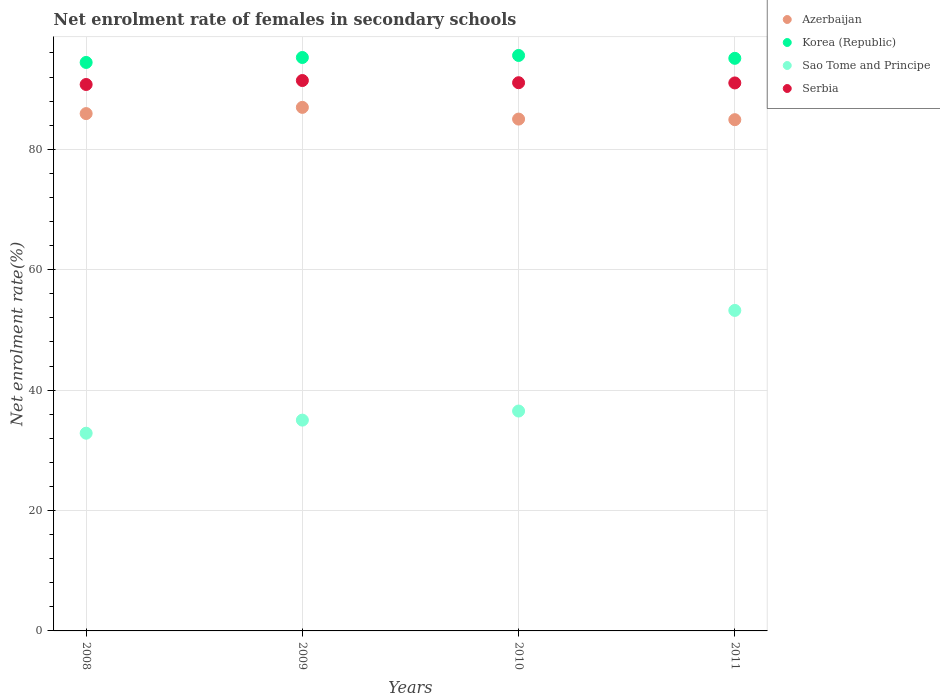How many different coloured dotlines are there?
Offer a very short reply. 4. Is the number of dotlines equal to the number of legend labels?
Provide a succinct answer. Yes. What is the net enrolment rate of females in secondary schools in Korea (Republic) in 2010?
Keep it short and to the point. 95.58. Across all years, what is the maximum net enrolment rate of females in secondary schools in Korea (Republic)?
Your answer should be compact. 95.58. Across all years, what is the minimum net enrolment rate of females in secondary schools in Sao Tome and Principe?
Ensure brevity in your answer.  32.84. In which year was the net enrolment rate of females in secondary schools in Korea (Republic) maximum?
Provide a succinct answer. 2010. What is the total net enrolment rate of females in secondary schools in Sao Tome and Principe in the graph?
Your response must be concise. 157.6. What is the difference between the net enrolment rate of females in secondary schools in Sao Tome and Principe in 2008 and that in 2009?
Provide a succinct answer. -2.17. What is the difference between the net enrolment rate of females in secondary schools in Sao Tome and Principe in 2008 and the net enrolment rate of females in secondary schools in Azerbaijan in 2010?
Provide a short and direct response. -52.17. What is the average net enrolment rate of females in secondary schools in Azerbaijan per year?
Your answer should be compact. 85.7. In the year 2008, what is the difference between the net enrolment rate of females in secondary schools in Azerbaijan and net enrolment rate of females in secondary schools in Sao Tome and Principe?
Your answer should be compact. 53.08. In how many years, is the net enrolment rate of females in secondary schools in Serbia greater than 32 %?
Make the answer very short. 4. What is the ratio of the net enrolment rate of females in secondary schools in Sao Tome and Principe in 2008 to that in 2009?
Offer a very short reply. 0.94. Is the difference between the net enrolment rate of females in secondary schools in Azerbaijan in 2010 and 2011 greater than the difference between the net enrolment rate of females in secondary schools in Sao Tome and Principe in 2010 and 2011?
Make the answer very short. Yes. What is the difference between the highest and the second highest net enrolment rate of females in secondary schools in Serbia?
Your answer should be compact. 0.36. What is the difference between the highest and the lowest net enrolment rate of females in secondary schools in Serbia?
Ensure brevity in your answer.  0.66. Is it the case that in every year, the sum of the net enrolment rate of females in secondary schools in Serbia and net enrolment rate of females in secondary schools in Azerbaijan  is greater than the sum of net enrolment rate of females in secondary schools in Sao Tome and Principe and net enrolment rate of females in secondary schools in Korea (Republic)?
Ensure brevity in your answer.  Yes. How many dotlines are there?
Provide a succinct answer. 4. What is the difference between two consecutive major ticks on the Y-axis?
Provide a succinct answer. 20. Does the graph contain any zero values?
Give a very brief answer. No. Does the graph contain grids?
Your answer should be compact. Yes. Where does the legend appear in the graph?
Your answer should be very brief. Top right. How many legend labels are there?
Ensure brevity in your answer.  4. What is the title of the graph?
Give a very brief answer. Net enrolment rate of females in secondary schools. Does "Vietnam" appear as one of the legend labels in the graph?
Offer a very short reply. No. What is the label or title of the X-axis?
Give a very brief answer. Years. What is the label or title of the Y-axis?
Make the answer very short. Net enrolment rate(%). What is the Net enrolment rate(%) in Azerbaijan in 2008?
Offer a terse response. 85.92. What is the Net enrolment rate(%) of Korea (Republic) in 2008?
Make the answer very short. 94.42. What is the Net enrolment rate(%) of Sao Tome and Principe in 2008?
Provide a succinct answer. 32.84. What is the Net enrolment rate(%) in Serbia in 2008?
Make the answer very short. 90.76. What is the Net enrolment rate(%) in Azerbaijan in 2009?
Ensure brevity in your answer.  86.96. What is the Net enrolment rate(%) of Korea (Republic) in 2009?
Keep it short and to the point. 95.24. What is the Net enrolment rate(%) of Sao Tome and Principe in 2009?
Keep it short and to the point. 35.01. What is the Net enrolment rate(%) in Serbia in 2009?
Keep it short and to the point. 91.42. What is the Net enrolment rate(%) in Azerbaijan in 2010?
Your answer should be very brief. 85.01. What is the Net enrolment rate(%) in Korea (Republic) in 2010?
Give a very brief answer. 95.58. What is the Net enrolment rate(%) in Sao Tome and Principe in 2010?
Ensure brevity in your answer.  36.52. What is the Net enrolment rate(%) in Serbia in 2010?
Your answer should be very brief. 91.05. What is the Net enrolment rate(%) in Azerbaijan in 2011?
Provide a short and direct response. 84.91. What is the Net enrolment rate(%) of Korea (Republic) in 2011?
Your answer should be very brief. 95.1. What is the Net enrolment rate(%) of Sao Tome and Principe in 2011?
Provide a short and direct response. 53.23. What is the Net enrolment rate(%) in Serbia in 2011?
Make the answer very short. 91.01. Across all years, what is the maximum Net enrolment rate(%) of Azerbaijan?
Offer a very short reply. 86.96. Across all years, what is the maximum Net enrolment rate(%) in Korea (Republic)?
Your response must be concise. 95.58. Across all years, what is the maximum Net enrolment rate(%) of Sao Tome and Principe?
Your answer should be very brief. 53.23. Across all years, what is the maximum Net enrolment rate(%) of Serbia?
Give a very brief answer. 91.42. Across all years, what is the minimum Net enrolment rate(%) in Azerbaijan?
Your answer should be compact. 84.91. Across all years, what is the minimum Net enrolment rate(%) of Korea (Republic)?
Keep it short and to the point. 94.42. Across all years, what is the minimum Net enrolment rate(%) of Sao Tome and Principe?
Give a very brief answer. 32.84. Across all years, what is the minimum Net enrolment rate(%) in Serbia?
Your answer should be very brief. 90.76. What is the total Net enrolment rate(%) of Azerbaijan in the graph?
Offer a very short reply. 342.8. What is the total Net enrolment rate(%) of Korea (Republic) in the graph?
Your response must be concise. 380.34. What is the total Net enrolment rate(%) of Sao Tome and Principe in the graph?
Provide a short and direct response. 157.6. What is the total Net enrolment rate(%) in Serbia in the graph?
Your answer should be very brief. 364.24. What is the difference between the Net enrolment rate(%) in Azerbaijan in 2008 and that in 2009?
Your answer should be compact. -1.03. What is the difference between the Net enrolment rate(%) in Korea (Republic) in 2008 and that in 2009?
Your answer should be compact. -0.82. What is the difference between the Net enrolment rate(%) of Sao Tome and Principe in 2008 and that in 2009?
Ensure brevity in your answer.  -2.17. What is the difference between the Net enrolment rate(%) in Serbia in 2008 and that in 2009?
Give a very brief answer. -0.66. What is the difference between the Net enrolment rate(%) of Azerbaijan in 2008 and that in 2010?
Give a very brief answer. 0.91. What is the difference between the Net enrolment rate(%) in Korea (Republic) in 2008 and that in 2010?
Your answer should be compact. -1.16. What is the difference between the Net enrolment rate(%) of Sao Tome and Principe in 2008 and that in 2010?
Your answer should be very brief. -3.68. What is the difference between the Net enrolment rate(%) in Serbia in 2008 and that in 2010?
Ensure brevity in your answer.  -0.3. What is the difference between the Net enrolment rate(%) in Azerbaijan in 2008 and that in 2011?
Keep it short and to the point. 1.01. What is the difference between the Net enrolment rate(%) in Korea (Republic) in 2008 and that in 2011?
Provide a succinct answer. -0.68. What is the difference between the Net enrolment rate(%) in Sao Tome and Principe in 2008 and that in 2011?
Ensure brevity in your answer.  -20.4. What is the difference between the Net enrolment rate(%) in Serbia in 2008 and that in 2011?
Keep it short and to the point. -0.26. What is the difference between the Net enrolment rate(%) of Azerbaijan in 2009 and that in 2010?
Ensure brevity in your answer.  1.95. What is the difference between the Net enrolment rate(%) in Korea (Republic) in 2009 and that in 2010?
Your answer should be compact. -0.34. What is the difference between the Net enrolment rate(%) of Sao Tome and Principe in 2009 and that in 2010?
Your answer should be compact. -1.51. What is the difference between the Net enrolment rate(%) of Serbia in 2009 and that in 2010?
Keep it short and to the point. 0.36. What is the difference between the Net enrolment rate(%) in Azerbaijan in 2009 and that in 2011?
Your answer should be compact. 2.04. What is the difference between the Net enrolment rate(%) in Korea (Republic) in 2009 and that in 2011?
Give a very brief answer. 0.14. What is the difference between the Net enrolment rate(%) of Sao Tome and Principe in 2009 and that in 2011?
Your answer should be very brief. -18.22. What is the difference between the Net enrolment rate(%) of Serbia in 2009 and that in 2011?
Provide a succinct answer. 0.4. What is the difference between the Net enrolment rate(%) in Azerbaijan in 2010 and that in 2011?
Give a very brief answer. 0.1. What is the difference between the Net enrolment rate(%) in Korea (Republic) in 2010 and that in 2011?
Ensure brevity in your answer.  0.48. What is the difference between the Net enrolment rate(%) in Sao Tome and Principe in 2010 and that in 2011?
Provide a short and direct response. -16.71. What is the difference between the Net enrolment rate(%) in Serbia in 2010 and that in 2011?
Keep it short and to the point. 0.04. What is the difference between the Net enrolment rate(%) of Azerbaijan in 2008 and the Net enrolment rate(%) of Korea (Republic) in 2009?
Provide a short and direct response. -9.32. What is the difference between the Net enrolment rate(%) of Azerbaijan in 2008 and the Net enrolment rate(%) of Sao Tome and Principe in 2009?
Your answer should be compact. 50.91. What is the difference between the Net enrolment rate(%) in Azerbaijan in 2008 and the Net enrolment rate(%) in Serbia in 2009?
Offer a very short reply. -5.49. What is the difference between the Net enrolment rate(%) in Korea (Republic) in 2008 and the Net enrolment rate(%) in Sao Tome and Principe in 2009?
Offer a terse response. 59.41. What is the difference between the Net enrolment rate(%) in Korea (Republic) in 2008 and the Net enrolment rate(%) in Serbia in 2009?
Provide a short and direct response. 3. What is the difference between the Net enrolment rate(%) of Sao Tome and Principe in 2008 and the Net enrolment rate(%) of Serbia in 2009?
Your response must be concise. -58.58. What is the difference between the Net enrolment rate(%) in Azerbaijan in 2008 and the Net enrolment rate(%) in Korea (Republic) in 2010?
Provide a short and direct response. -9.66. What is the difference between the Net enrolment rate(%) of Azerbaijan in 2008 and the Net enrolment rate(%) of Sao Tome and Principe in 2010?
Offer a terse response. 49.4. What is the difference between the Net enrolment rate(%) of Azerbaijan in 2008 and the Net enrolment rate(%) of Serbia in 2010?
Provide a short and direct response. -5.13. What is the difference between the Net enrolment rate(%) in Korea (Republic) in 2008 and the Net enrolment rate(%) in Sao Tome and Principe in 2010?
Keep it short and to the point. 57.9. What is the difference between the Net enrolment rate(%) of Korea (Republic) in 2008 and the Net enrolment rate(%) of Serbia in 2010?
Provide a succinct answer. 3.37. What is the difference between the Net enrolment rate(%) of Sao Tome and Principe in 2008 and the Net enrolment rate(%) of Serbia in 2010?
Offer a very short reply. -58.21. What is the difference between the Net enrolment rate(%) in Azerbaijan in 2008 and the Net enrolment rate(%) in Korea (Republic) in 2011?
Your answer should be compact. -9.18. What is the difference between the Net enrolment rate(%) of Azerbaijan in 2008 and the Net enrolment rate(%) of Sao Tome and Principe in 2011?
Offer a very short reply. 32.69. What is the difference between the Net enrolment rate(%) of Azerbaijan in 2008 and the Net enrolment rate(%) of Serbia in 2011?
Ensure brevity in your answer.  -5.09. What is the difference between the Net enrolment rate(%) in Korea (Republic) in 2008 and the Net enrolment rate(%) in Sao Tome and Principe in 2011?
Your response must be concise. 41.18. What is the difference between the Net enrolment rate(%) in Korea (Republic) in 2008 and the Net enrolment rate(%) in Serbia in 2011?
Your answer should be compact. 3.4. What is the difference between the Net enrolment rate(%) in Sao Tome and Principe in 2008 and the Net enrolment rate(%) in Serbia in 2011?
Make the answer very short. -58.18. What is the difference between the Net enrolment rate(%) in Azerbaijan in 2009 and the Net enrolment rate(%) in Korea (Republic) in 2010?
Ensure brevity in your answer.  -8.62. What is the difference between the Net enrolment rate(%) of Azerbaijan in 2009 and the Net enrolment rate(%) of Sao Tome and Principe in 2010?
Provide a succinct answer. 50.44. What is the difference between the Net enrolment rate(%) of Azerbaijan in 2009 and the Net enrolment rate(%) of Serbia in 2010?
Provide a short and direct response. -4.09. What is the difference between the Net enrolment rate(%) of Korea (Republic) in 2009 and the Net enrolment rate(%) of Sao Tome and Principe in 2010?
Your answer should be very brief. 58.72. What is the difference between the Net enrolment rate(%) in Korea (Republic) in 2009 and the Net enrolment rate(%) in Serbia in 2010?
Your response must be concise. 4.19. What is the difference between the Net enrolment rate(%) in Sao Tome and Principe in 2009 and the Net enrolment rate(%) in Serbia in 2010?
Give a very brief answer. -56.04. What is the difference between the Net enrolment rate(%) of Azerbaijan in 2009 and the Net enrolment rate(%) of Korea (Republic) in 2011?
Offer a terse response. -8.14. What is the difference between the Net enrolment rate(%) of Azerbaijan in 2009 and the Net enrolment rate(%) of Sao Tome and Principe in 2011?
Ensure brevity in your answer.  33.72. What is the difference between the Net enrolment rate(%) in Azerbaijan in 2009 and the Net enrolment rate(%) in Serbia in 2011?
Offer a very short reply. -4.06. What is the difference between the Net enrolment rate(%) of Korea (Republic) in 2009 and the Net enrolment rate(%) of Sao Tome and Principe in 2011?
Provide a short and direct response. 42.01. What is the difference between the Net enrolment rate(%) of Korea (Republic) in 2009 and the Net enrolment rate(%) of Serbia in 2011?
Your response must be concise. 4.23. What is the difference between the Net enrolment rate(%) of Sao Tome and Principe in 2009 and the Net enrolment rate(%) of Serbia in 2011?
Your answer should be compact. -56. What is the difference between the Net enrolment rate(%) of Azerbaijan in 2010 and the Net enrolment rate(%) of Korea (Republic) in 2011?
Offer a very short reply. -10.09. What is the difference between the Net enrolment rate(%) in Azerbaijan in 2010 and the Net enrolment rate(%) in Sao Tome and Principe in 2011?
Offer a terse response. 31.78. What is the difference between the Net enrolment rate(%) of Azerbaijan in 2010 and the Net enrolment rate(%) of Serbia in 2011?
Keep it short and to the point. -6. What is the difference between the Net enrolment rate(%) in Korea (Republic) in 2010 and the Net enrolment rate(%) in Sao Tome and Principe in 2011?
Offer a terse response. 42.34. What is the difference between the Net enrolment rate(%) of Korea (Republic) in 2010 and the Net enrolment rate(%) of Serbia in 2011?
Offer a terse response. 4.56. What is the difference between the Net enrolment rate(%) of Sao Tome and Principe in 2010 and the Net enrolment rate(%) of Serbia in 2011?
Your answer should be very brief. -54.49. What is the average Net enrolment rate(%) of Azerbaijan per year?
Offer a terse response. 85.7. What is the average Net enrolment rate(%) of Korea (Republic) per year?
Provide a short and direct response. 95.08. What is the average Net enrolment rate(%) of Sao Tome and Principe per year?
Ensure brevity in your answer.  39.4. What is the average Net enrolment rate(%) in Serbia per year?
Provide a short and direct response. 91.06. In the year 2008, what is the difference between the Net enrolment rate(%) in Azerbaijan and Net enrolment rate(%) in Korea (Republic)?
Provide a short and direct response. -8.5. In the year 2008, what is the difference between the Net enrolment rate(%) in Azerbaijan and Net enrolment rate(%) in Sao Tome and Principe?
Provide a short and direct response. 53.08. In the year 2008, what is the difference between the Net enrolment rate(%) of Azerbaijan and Net enrolment rate(%) of Serbia?
Ensure brevity in your answer.  -4.83. In the year 2008, what is the difference between the Net enrolment rate(%) in Korea (Republic) and Net enrolment rate(%) in Sao Tome and Principe?
Your answer should be very brief. 61.58. In the year 2008, what is the difference between the Net enrolment rate(%) in Korea (Republic) and Net enrolment rate(%) in Serbia?
Ensure brevity in your answer.  3.66. In the year 2008, what is the difference between the Net enrolment rate(%) of Sao Tome and Principe and Net enrolment rate(%) of Serbia?
Give a very brief answer. -57.92. In the year 2009, what is the difference between the Net enrolment rate(%) of Azerbaijan and Net enrolment rate(%) of Korea (Republic)?
Offer a very short reply. -8.28. In the year 2009, what is the difference between the Net enrolment rate(%) in Azerbaijan and Net enrolment rate(%) in Sao Tome and Principe?
Offer a terse response. 51.95. In the year 2009, what is the difference between the Net enrolment rate(%) of Azerbaijan and Net enrolment rate(%) of Serbia?
Give a very brief answer. -4.46. In the year 2009, what is the difference between the Net enrolment rate(%) in Korea (Republic) and Net enrolment rate(%) in Sao Tome and Principe?
Ensure brevity in your answer.  60.23. In the year 2009, what is the difference between the Net enrolment rate(%) in Korea (Republic) and Net enrolment rate(%) in Serbia?
Give a very brief answer. 3.82. In the year 2009, what is the difference between the Net enrolment rate(%) in Sao Tome and Principe and Net enrolment rate(%) in Serbia?
Ensure brevity in your answer.  -56.4. In the year 2010, what is the difference between the Net enrolment rate(%) in Azerbaijan and Net enrolment rate(%) in Korea (Republic)?
Keep it short and to the point. -10.57. In the year 2010, what is the difference between the Net enrolment rate(%) of Azerbaijan and Net enrolment rate(%) of Sao Tome and Principe?
Make the answer very short. 48.49. In the year 2010, what is the difference between the Net enrolment rate(%) of Azerbaijan and Net enrolment rate(%) of Serbia?
Offer a terse response. -6.04. In the year 2010, what is the difference between the Net enrolment rate(%) in Korea (Republic) and Net enrolment rate(%) in Sao Tome and Principe?
Offer a terse response. 59.06. In the year 2010, what is the difference between the Net enrolment rate(%) in Korea (Republic) and Net enrolment rate(%) in Serbia?
Provide a short and direct response. 4.53. In the year 2010, what is the difference between the Net enrolment rate(%) of Sao Tome and Principe and Net enrolment rate(%) of Serbia?
Provide a succinct answer. -54.53. In the year 2011, what is the difference between the Net enrolment rate(%) in Azerbaijan and Net enrolment rate(%) in Korea (Republic)?
Keep it short and to the point. -10.19. In the year 2011, what is the difference between the Net enrolment rate(%) in Azerbaijan and Net enrolment rate(%) in Sao Tome and Principe?
Ensure brevity in your answer.  31.68. In the year 2011, what is the difference between the Net enrolment rate(%) in Azerbaijan and Net enrolment rate(%) in Serbia?
Offer a terse response. -6.1. In the year 2011, what is the difference between the Net enrolment rate(%) of Korea (Republic) and Net enrolment rate(%) of Sao Tome and Principe?
Make the answer very short. 41.87. In the year 2011, what is the difference between the Net enrolment rate(%) of Korea (Republic) and Net enrolment rate(%) of Serbia?
Make the answer very short. 4.09. In the year 2011, what is the difference between the Net enrolment rate(%) in Sao Tome and Principe and Net enrolment rate(%) in Serbia?
Your answer should be very brief. -37.78. What is the ratio of the Net enrolment rate(%) in Korea (Republic) in 2008 to that in 2009?
Provide a short and direct response. 0.99. What is the ratio of the Net enrolment rate(%) of Sao Tome and Principe in 2008 to that in 2009?
Your response must be concise. 0.94. What is the ratio of the Net enrolment rate(%) in Serbia in 2008 to that in 2009?
Offer a terse response. 0.99. What is the ratio of the Net enrolment rate(%) in Azerbaijan in 2008 to that in 2010?
Make the answer very short. 1.01. What is the ratio of the Net enrolment rate(%) of Korea (Republic) in 2008 to that in 2010?
Your answer should be very brief. 0.99. What is the ratio of the Net enrolment rate(%) of Sao Tome and Principe in 2008 to that in 2010?
Give a very brief answer. 0.9. What is the ratio of the Net enrolment rate(%) of Serbia in 2008 to that in 2010?
Your answer should be very brief. 1. What is the ratio of the Net enrolment rate(%) of Azerbaijan in 2008 to that in 2011?
Your answer should be very brief. 1.01. What is the ratio of the Net enrolment rate(%) in Sao Tome and Principe in 2008 to that in 2011?
Provide a succinct answer. 0.62. What is the ratio of the Net enrolment rate(%) in Azerbaijan in 2009 to that in 2010?
Keep it short and to the point. 1.02. What is the ratio of the Net enrolment rate(%) of Sao Tome and Principe in 2009 to that in 2010?
Your response must be concise. 0.96. What is the ratio of the Net enrolment rate(%) in Serbia in 2009 to that in 2010?
Give a very brief answer. 1. What is the ratio of the Net enrolment rate(%) in Azerbaijan in 2009 to that in 2011?
Keep it short and to the point. 1.02. What is the ratio of the Net enrolment rate(%) of Sao Tome and Principe in 2009 to that in 2011?
Give a very brief answer. 0.66. What is the ratio of the Net enrolment rate(%) of Serbia in 2009 to that in 2011?
Offer a terse response. 1. What is the ratio of the Net enrolment rate(%) of Azerbaijan in 2010 to that in 2011?
Your response must be concise. 1. What is the ratio of the Net enrolment rate(%) in Korea (Republic) in 2010 to that in 2011?
Provide a short and direct response. 1. What is the ratio of the Net enrolment rate(%) in Sao Tome and Principe in 2010 to that in 2011?
Give a very brief answer. 0.69. What is the difference between the highest and the second highest Net enrolment rate(%) of Azerbaijan?
Offer a very short reply. 1.03. What is the difference between the highest and the second highest Net enrolment rate(%) of Korea (Republic)?
Your answer should be very brief. 0.34. What is the difference between the highest and the second highest Net enrolment rate(%) of Sao Tome and Principe?
Offer a terse response. 16.71. What is the difference between the highest and the second highest Net enrolment rate(%) in Serbia?
Make the answer very short. 0.36. What is the difference between the highest and the lowest Net enrolment rate(%) of Azerbaijan?
Your answer should be compact. 2.04. What is the difference between the highest and the lowest Net enrolment rate(%) of Korea (Republic)?
Give a very brief answer. 1.16. What is the difference between the highest and the lowest Net enrolment rate(%) in Sao Tome and Principe?
Give a very brief answer. 20.4. What is the difference between the highest and the lowest Net enrolment rate(%) of Serbia?
Your answer should be compact. 0.66. 